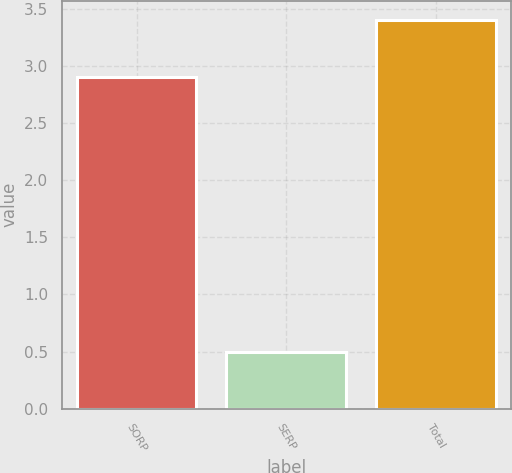Convert chart. <chart><loc_0><loc_0><loc_500><loc_500><bar_chart><fcel>SORP<fcel>SERP<fcel>Total<nl><fcel>2.9<fcel>0.5<fcel>3.4<nl></chart> 